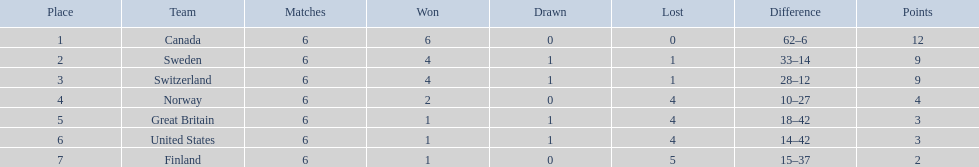Between switzerland and great britain, who had a superior performance in the 1951 world ice hockey championships? Switzerland. 